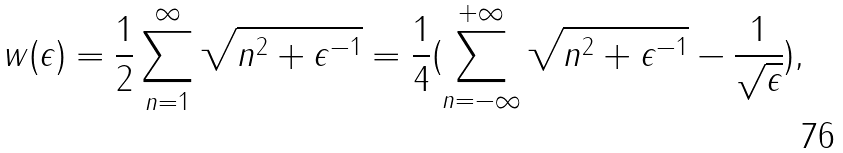<formula> <loc_0><loc_0><loc_500><loc_500>w ( \epsilon ) = \frac { 1 } { 2 } \sum _ { n = 1 } ^ { \infty } \sqrt { n ^ { 2 } + \epsilon ^ { - 1 } } = \frac { 1 } { 4 } ( \sum _ { n = - \infty } ^ { + \infty } \sqrt { n ^ { 2 } + \epsilon ^ { - 1 } } - \frac { 1 } { \sqrt { \epsilon } } ) ,</formula> 